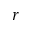Convert formula to latex. <formula><loc_0><loc_0><loc_500><loc_500>r</formula> 